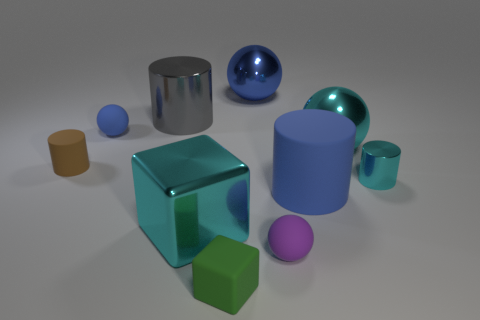What is the shape of the blue matte thing that is the same size as the cyan shiny ball?
Provide a succinct answer. Cylinder. Is there another metal thing that has the same size as the gray object?
Ensure brevity in your answer.  Yes. There is another ball that is the same size as the purple sphere; what is its material?
Your answer should be compact. Rubber. What is the size of the matte sphere that is on the right side of the green rubber cube that is in front of the brown rubber object?
Provide a succinct answer. Small. There is a cyan object left of the cyan shiny sphere; does it have the same size as the large gray cylinder?
Make the answer very short. Yes. Is the number of tiny green matte blocks that are behind the gray object greater than the number of cyan balls that are left of the green rubber thing?
Provide a short and direct response. No. What is the shape of the blue object that is both on the right side of the green thing and behind the cyan metal ball?
Ensure brevity in your answer.  Sphere. The cyan metal thing left of the green object has what shape?
Provide a succinct answer. Cube. How big is the rubber sphere on the left side of the metal cylinder behind the large cyan object that is right of the purple matte sphere?
Provide a succinct answer. Small. Is the shape of the brown matte object the same as the tiny cyan metal object?
Offer a very short reply. Yes. 